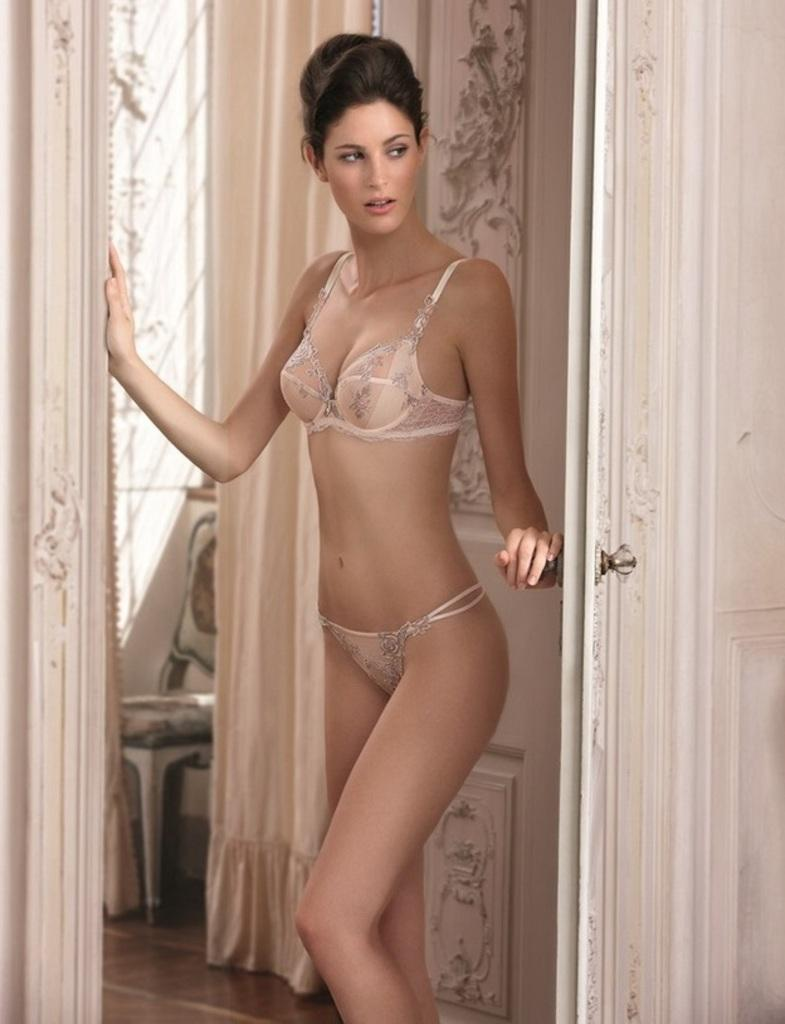What is the main subject of the image? There is a woman standing in the image. What is the woman wearing? The woman is wearing underwears. What can be seen in the background of the image? There is a door, the floor, a chair, and curtains visible in the image. How many bears are sitting on the chair in the image? There are no bears present in the image; it features a woman standing and various background elements. What type of mice can be seen crawling on the curtains in the image? There are no mice present on the curtains or anywhere else in the image. 